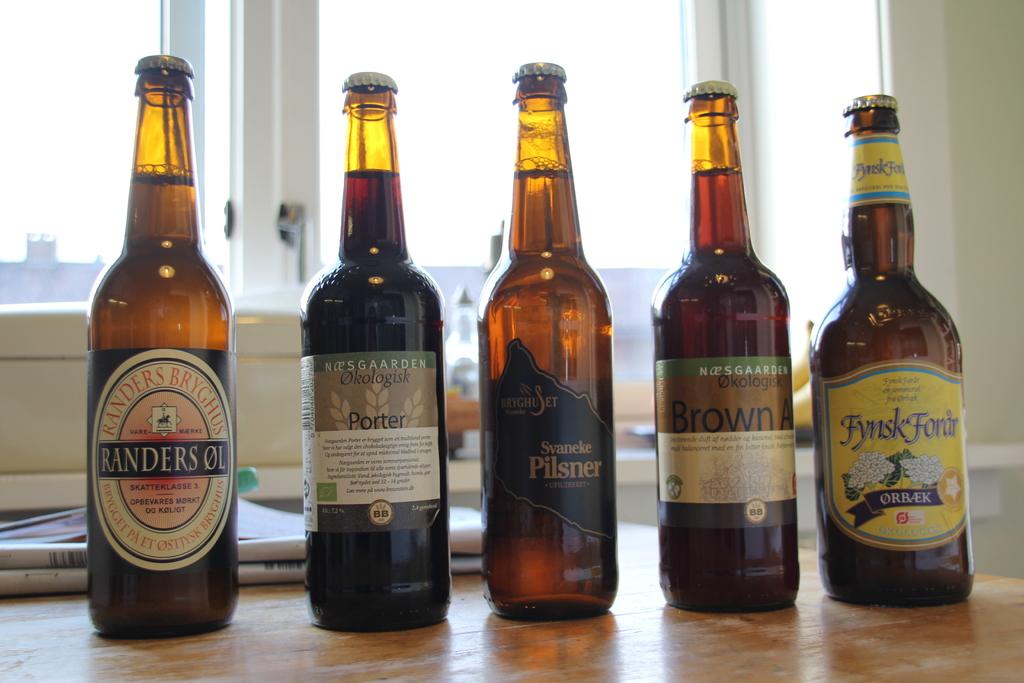What brand of beer?
Your response must be concise. Unanswerable. 